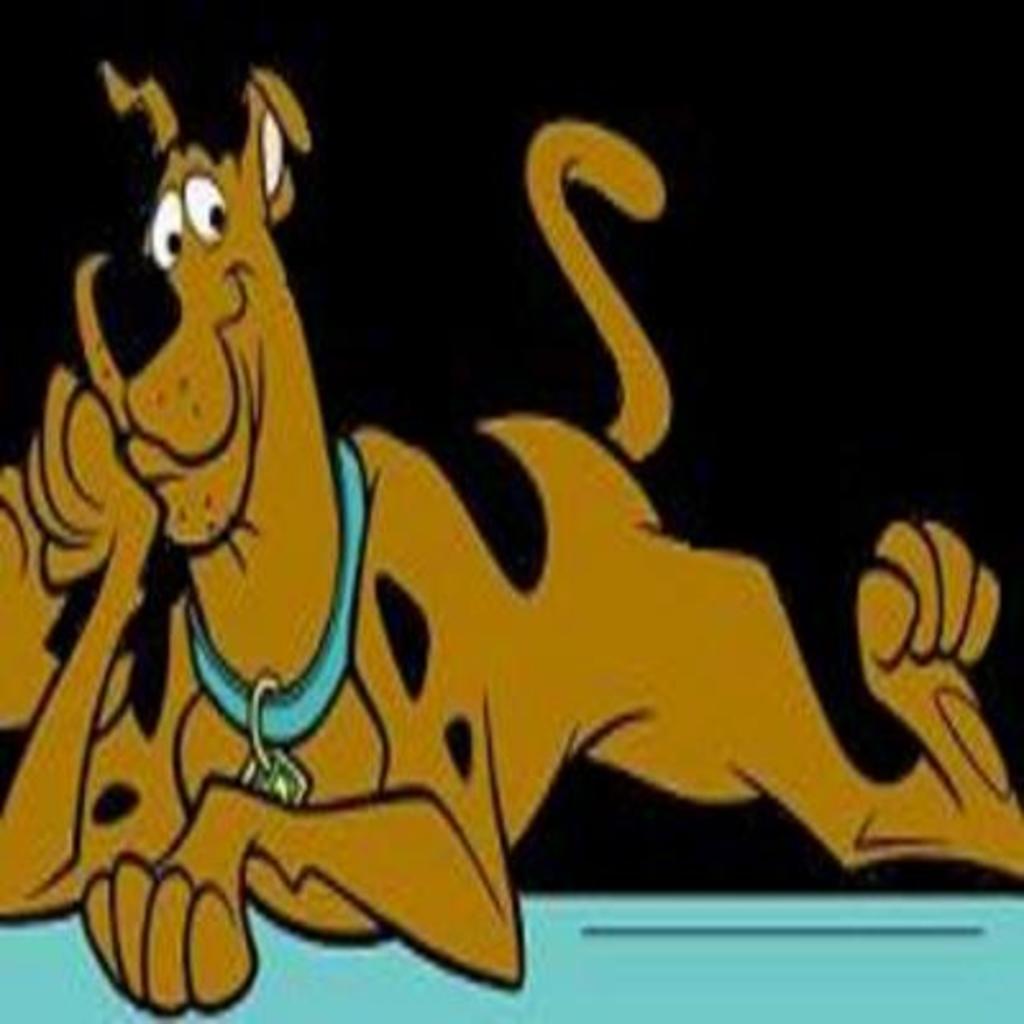How would you summarize this image in a sentence or two? In this image I can see the cartoon picture of the dog and the dog is in brown and black color and I can see the dark background. 